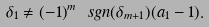Convert formula to latex. <formula><loc_0><loc_0><loc_500><loc_500>\delta _ { 1 } \not = ( - 1 ) ^ { m } \ s g n ( \delta _ { m + 1 } ) ( a _ { 1 } - 1 ) .</formula> 